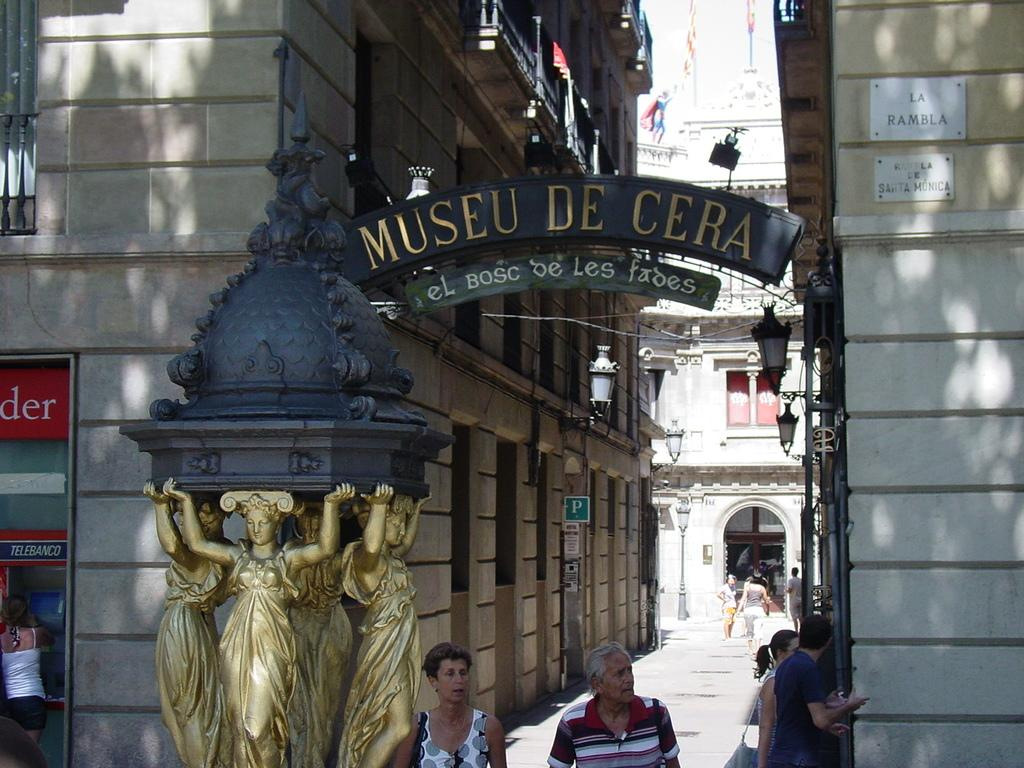What type of structures can be seen in the image? There are buildings in the image. Who or what else is present in the image? There are people in the image. What objects can be seen in addition to the buildings and people? There are boards in the image. How many feet are visible on the kitten in the image? There is no kitten present in the image, so it is not possible to determine the number of feet visible on a kitten. 